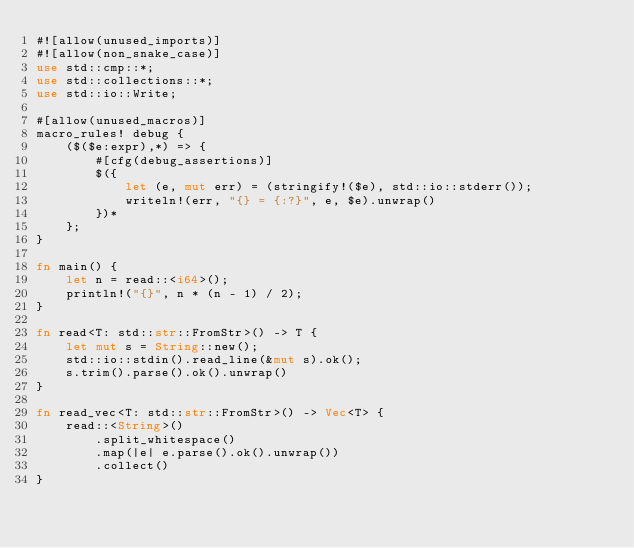Convert code to text. <code><loc_0><loc_0><loc_500><loc_500><_Rust_>#![allow(unused_imports)]
#![allow(non_snake_case)]
use std::cmp::*;
use std::collections::*;
use std::io::Write;

#[allow(unused_macros)]
macro_rules! debug {
    ($($e:expr),*) => {
        #[cfg(debug_assertions)]
        $({
            let (e, mut err) = (stringify!($e), std::io::stderr());
            writeln!(err, "{} = {:?}", e, $e).unwrap()
        })*
    };
}

fn main() {
    let n = read::<i64>();
    println!("{}", n * (n - 1) / 2);
}

fn read<T: std::str::FromStr>() -> T {
    let mut s = String::new();
    std::io::stdin().read_line(&mut s).ok();
    s.trim().parse().ok().unwrap()
}

fn read_vec<T: std::str::FromStr>() -> Vec<T> {
    read::<String>()
        .split_whitespace()
        .map(|e| e.parse().ok().unwrap())
        .collect()
}
</code> 